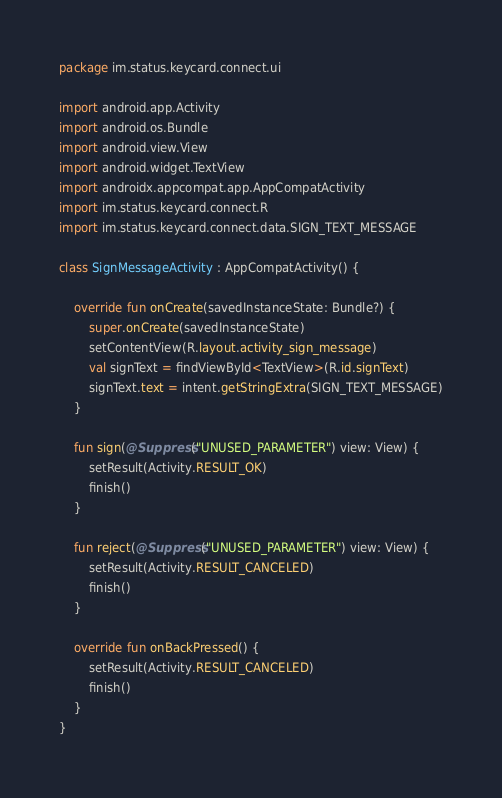Convert code to text. <code><loc_0><loc_0><loc_500><loc_500><_Kotlin_>package im.status.keycard.connect.ui

import android.app.Activity
import android.os.Bundle
import android.view.View
import android.widget.TextView
import androidx.appcompat.app.AppCompatActivity
import im.status.keycard.connect.R
import im.status.keycard.connect.data.SIGN_TEXT_MESSAGE

class SignMessageActivity : AppCompatActivity() {

    override fun onCreate(savedInstanceState: Bundle?) {
        super.onCreate(savedInstanceState)
        setContentView(R.layout.activity_sign_message)
        val signText = findViewById<TextView>(R.id.signText)
        signText.text = intent.getStringExtra(SIGN_TEXT_MESSAGE)
    }

    fun sign(@Suppress("UNUSED_PARAMETER") view: View) {
        setResult(Activity.RESULT_OK)
        finish()
    }

    fun reject(@Suppress("UNUSED_PARAMETER") view: View) {
        setResult(Activity.RESULT_CANCELED)
        finish()
    }

    override fun onBackPressed() {
        setResult(Activity.RESULT_CANCELED)
        finish()
    }
}
</code> 